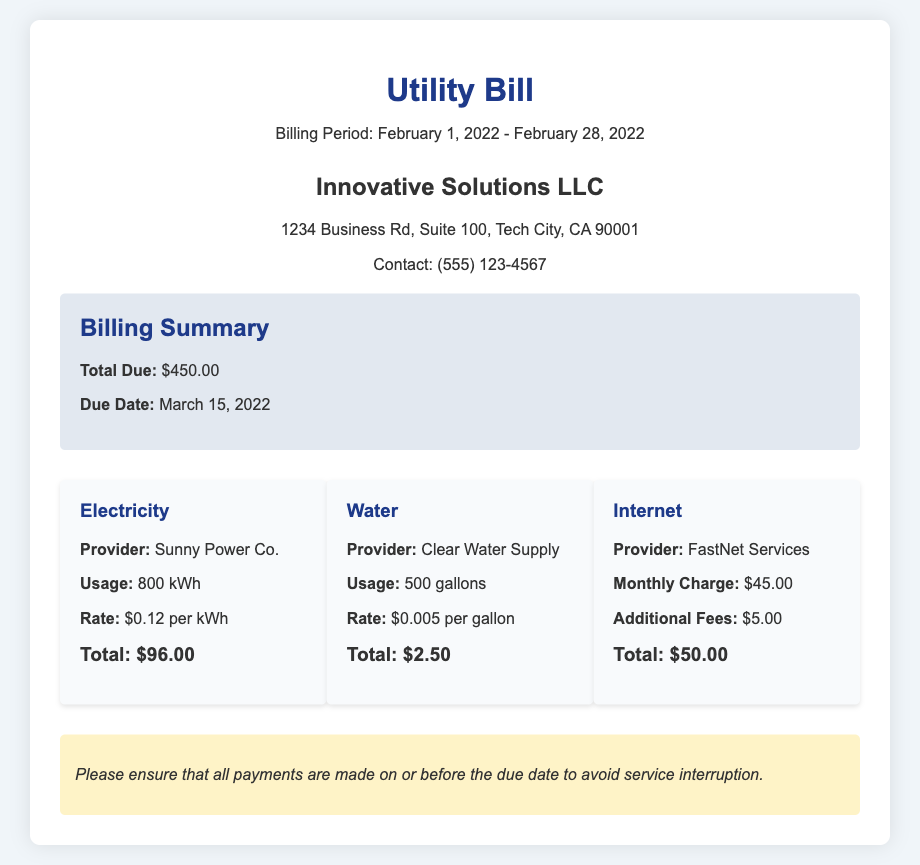What is the billing period? The billing period is specified in the document as February 1, 2022 to February 28, 2022.
Answer: February 1, 2022 - February 28, 2022 What is the total due amount? The total due amount is clearly stated in the billing summary section of the document.
Answer: $450.00 What is the due date for payment? The due date is provided in the billing summary and indicates when the payment must be made.
Answer: March 15, 2022 How much was charged for electricity? The total amount charged for electricity is noted under the breakdown for electricity services.
Answer: $96.00 What is the water usage amount? The document specifies the amount of water used as part of the details in the breakdown section for water services.
Answer: 500 gallons What is the monthly charge for internet services? The document lists the monthly charge for internet services separately in the breakdown area.
Answer: $45.00 Who is the provider for water services? The document states the water service provider in the breakdown section for water services.
Answer: Clear Water Supply What was the rate per kWh for electricity? The document provides the rate for electricity per kWh in the breakdown section for electricity services.
Answer: $0.12 per kWh What should be ensured to avoid service interruption? The document includes a note highlighting the importance of timely payments to prevent issues.
Answer: All payments are made on or before the due date 